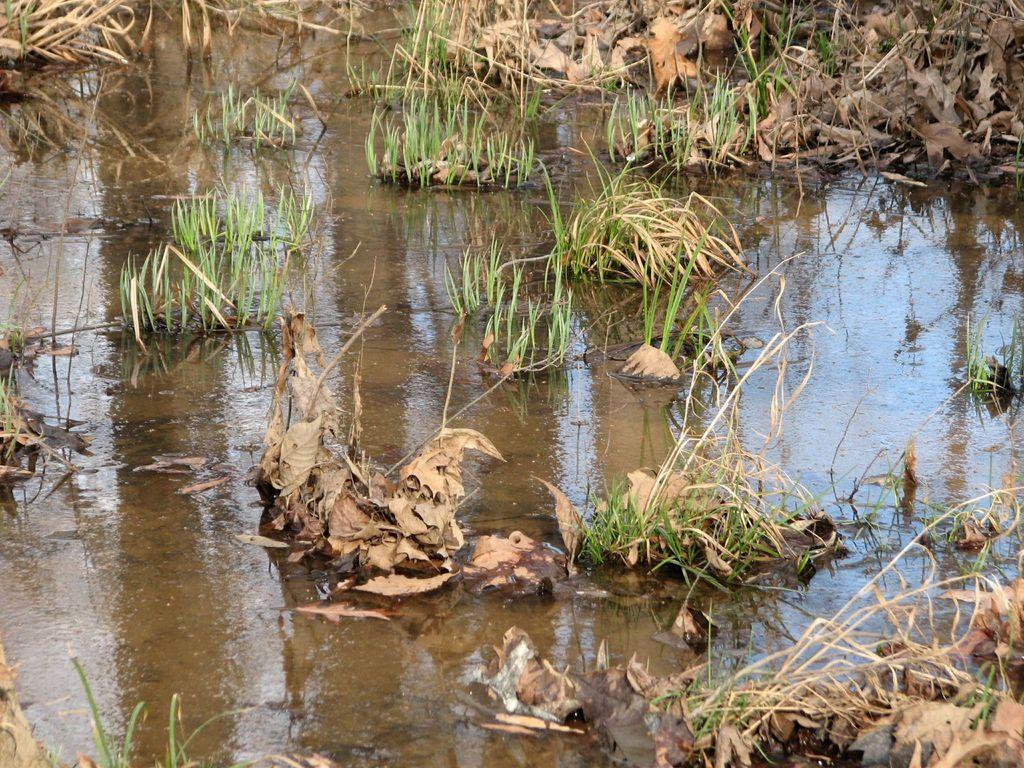What type of environment is depicted in the image? The image shows a natural environment with water and grass visible. Can you describe the water in the image? The water is visible in the image, but there is no specific detail about its characteristics. What type of vegetation can be seen in the image? Grass is visible in the image. How does the quiet pocket of thrill affect the water in the image? There is no mention of a quiet pocket of thrill in the image, so this question cannot be answered. 